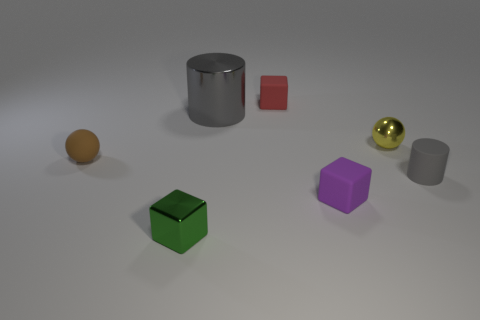Add 1 small purple matte blocks. How many objects exist? 8 Subtract all cubes. How many objects are left? 4 Add 3 large brown blocks. How many large brown blocks exist? 3 Subtract 0 gray blocks. How many objects are left? 7 Subtract all tiny metal balls. Subtract all large purple things. How many objects are left? 6 Add 4 large gray shiny cylinders. How many large gray shiny cylinders are left? 5 